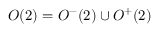Convert formula to latex. <formula><loc_0><loc_0><loc_500><loc_500>O ( 2 ) = O ^ { - } ( 2 ) \cup O ^ { + } ( 2 )</formula> 